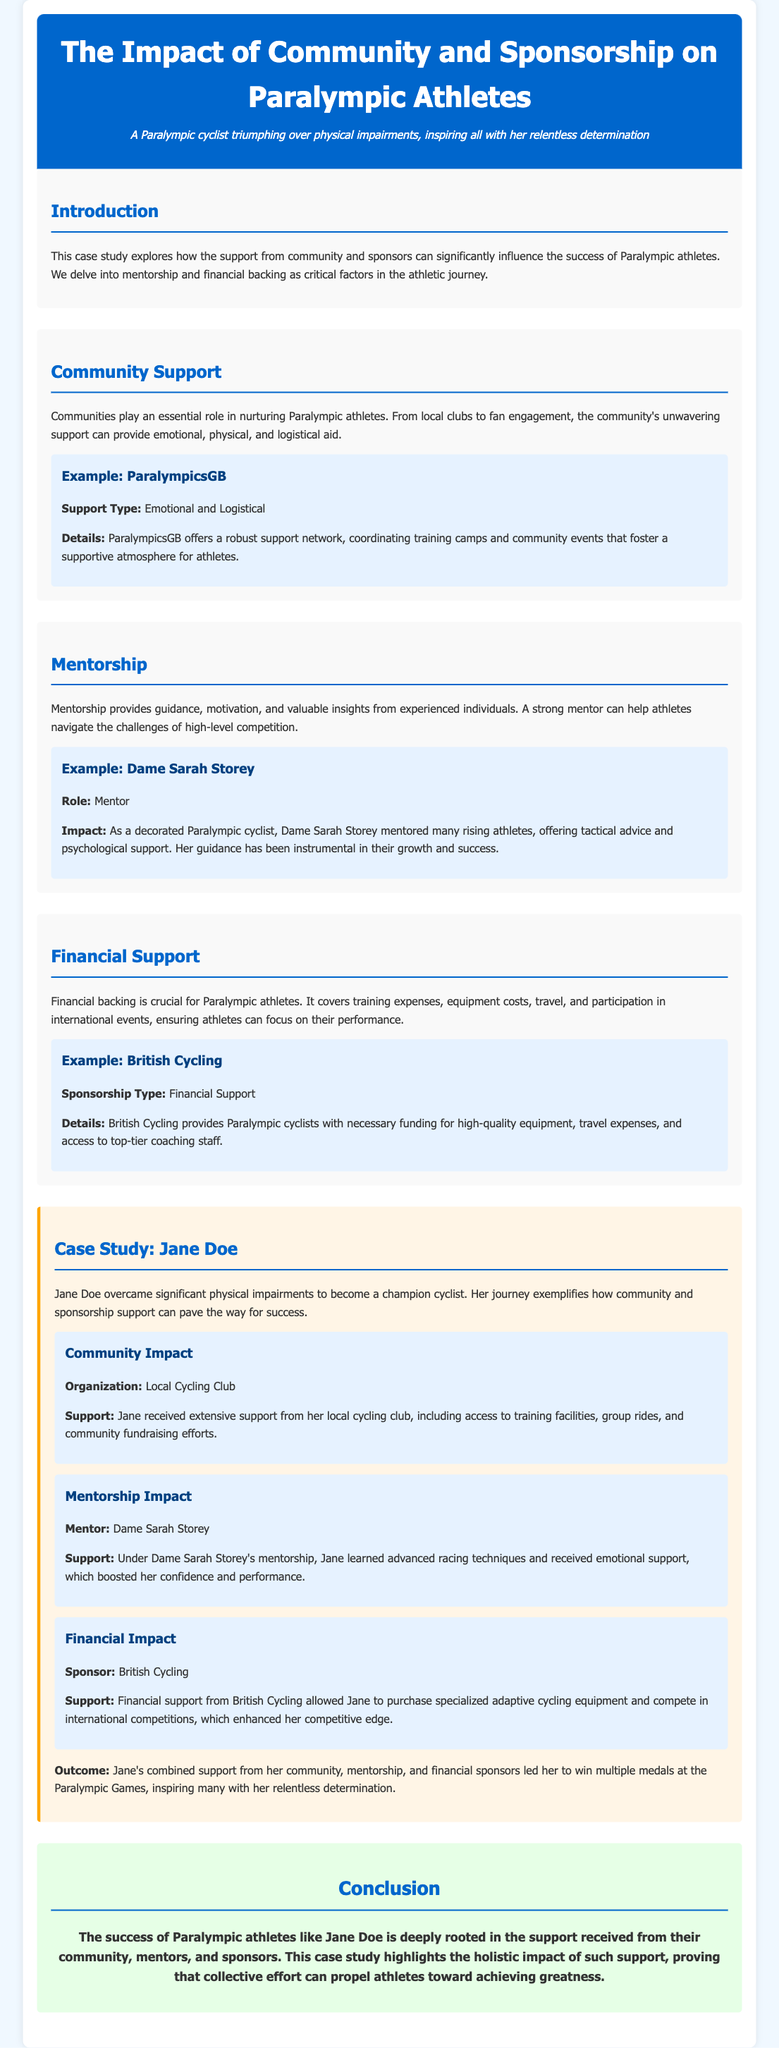What does this case study explore? The case study explores the influence of community and sponsors on the success of Paralympic athletes.
Answer: Community and sponsors Who is mentioned as a mentor in this study? Dame Sarah Storey is mentioned as a mentor who provides support to athletes.
Answer: Dame Sarah Storey What type of support does British Cycling provide? British Cycling provides financial support necessary for athletes to succeed.
Answer: Financial Support Which athlete's journey is highlighted in this case study? The case study highlights the journey of Jane Doe, a champion cyclist.
Answer: Jane Doe What organization provided extensive support to Jane Doe? Jane received extensive support from her local cycling club.
Answer: Local Cycling Club How did community engagement contribute to Jane Doe's success? Community engagement provided her access to training facilities and fundraising efforts.
Answer: Access to training facilities and fundraising efforts What was the outcome of Jane Doe's combined support? Jane won multiple medals at the Paralympic Games.
Answer: Multiple medals What role did financial support play in Jane Doe's career? Financial support allowed her to purchase specialized adaptive cycling equipment.
Answer: Purchase of specialized adaptive cycling equipment What is the conclusion of the case study? The conclusion highlights the holistic impact of support from community, mentors, and sponsors.
Answer: Holistic impact of support 